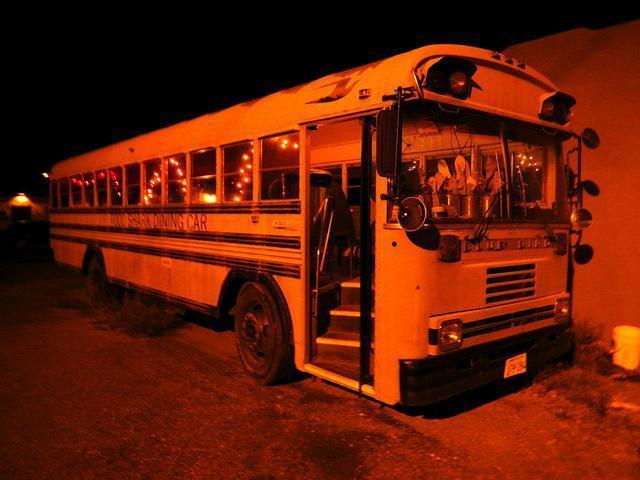How many trains are in front of the building?
Give a very brief answer. 0. 